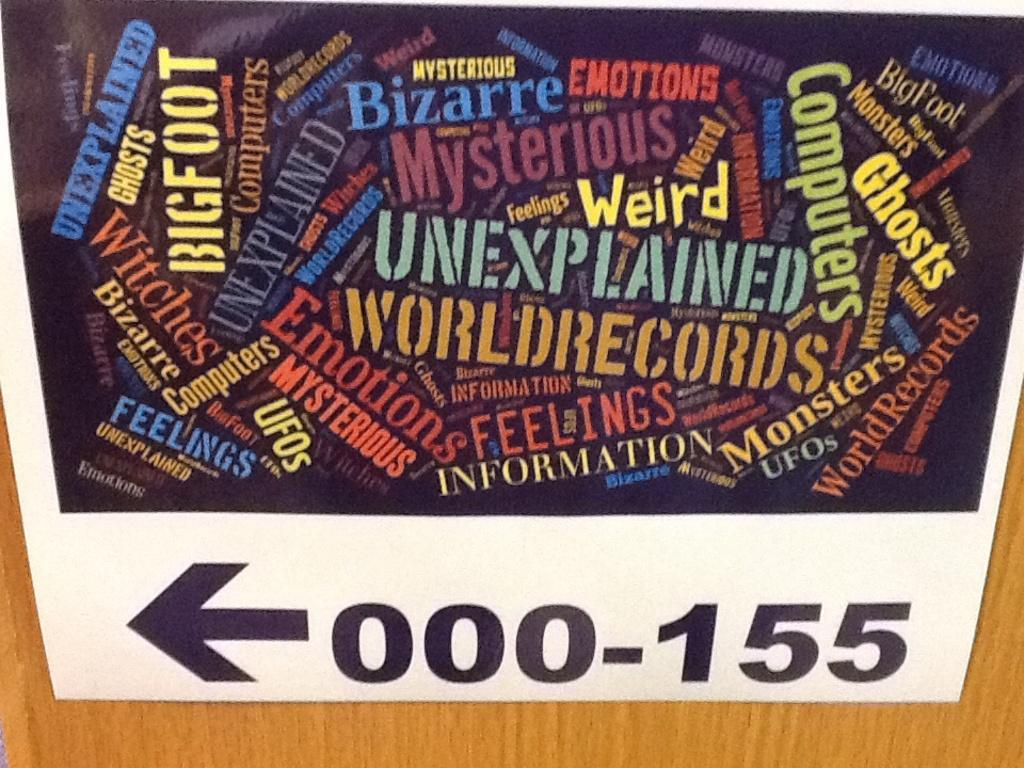<image>
Give a short and clear explanation of the subsequent image. The sign points to the left in order to find 000-155. 